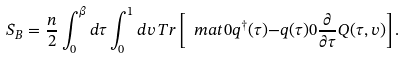<formula> <loc_0><loc_0><loc_500><loc_500>S _ { B } = \frac { n } { 2 } \int _ { 0 } ^ { \beta } d \tau \int _ { 0 } ^ { 1 } d v \, T r \left [ \ m a t { 0 } { q ^ { \dag } ( \tau ) } { - q ( \tau ) } { 0 } \frac { \partial } { \partial \tau } Q ( \tau , v ) \right ] .</formula> 